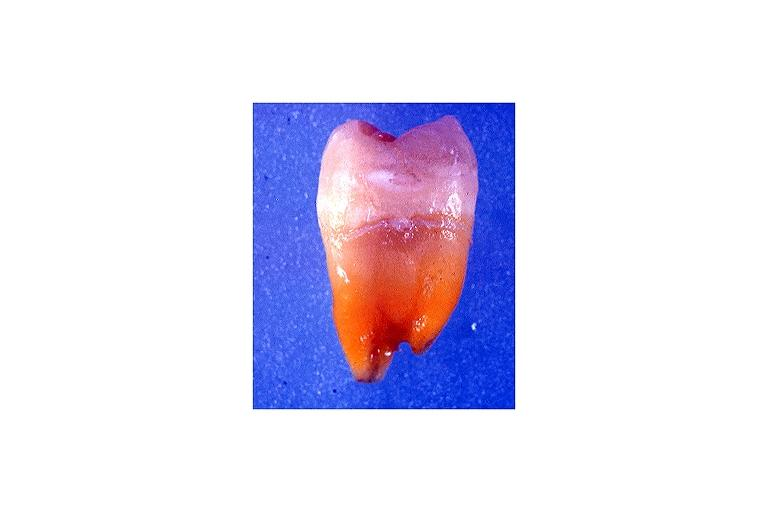what is tetracycline induced?
Answer the question using a single word or phrase. Discoloration 